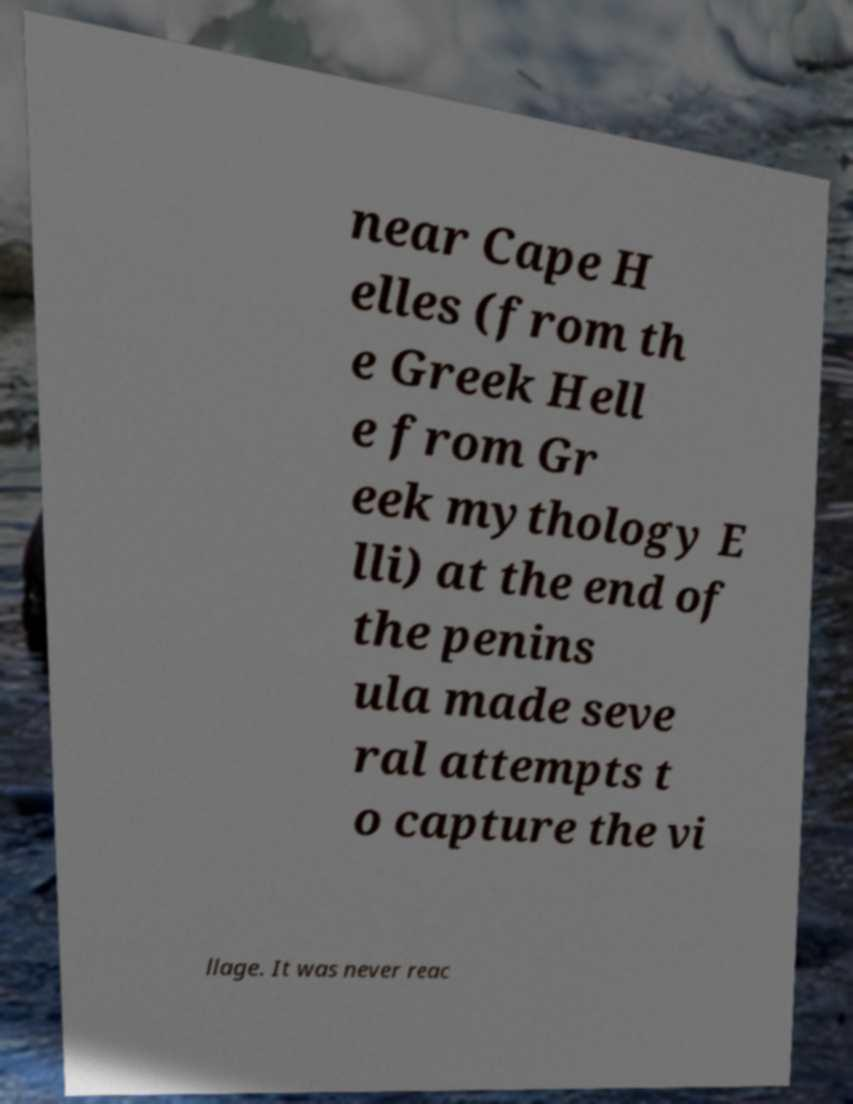For documentation purposes, I need the text within this image transcribed. Could you provide that? near Cape H elles (from th e Greek Hell e from Gr eek mythology E lli) at the end of the penins ula made seve ral attempts t o capture the vi llage. It was never reac 